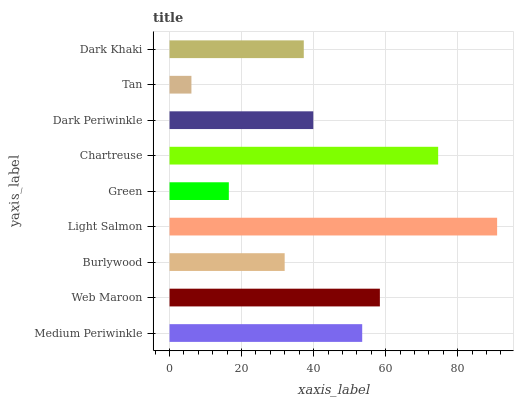Is Tan the minimum?
Answer yes or no. Yes. Is Light Salmon the maximum?
Answer yes or no. Yes. Is Web Maroon the minimum?
Answer yes or no. No. Is Web Maroon the maximum?
Answer yes or no. No. Is Web Maroon greater than Medium Periwinkle?
Answer yes or no. Yes. Is Medium Periwinkle less than Web Maroon?
Answer yes or no. Yes. Is Medium Periwinkle greater than Web Maroon?
Answer yes or no. No. Is Web Maroon less than Medium Periwinkle?
Answer yes or no. No. Is Dark Periwinkle the high median?
Answer yes or no. Yes. Is Dark Periwinkle the low median?
Answer yes or no. Yes. Is Web Maroon the high median?
Answer yes or no. No. Is Chartreuse the low median?
Answer yes or no. No. 